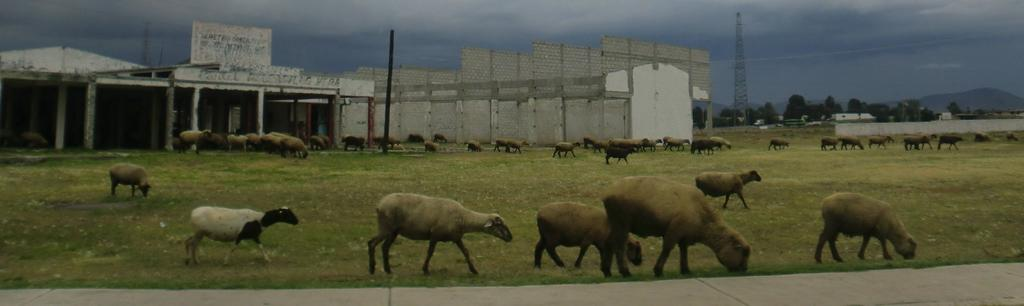What types of living organisms can be seen in the image? There are animals in the image. What are the animals doing in the image? The animals are walking on the grass. What can be seen in the background of the image? There is a building, huge walls with bricks, a tower, trees, and the sky visible in the background of the image. What type of market can be seen in the image? There is no market present in the image; it features animals walking on the grass and various background elements. What kind of rock formation is visible in the image? There is no rock formation visible in the image. 